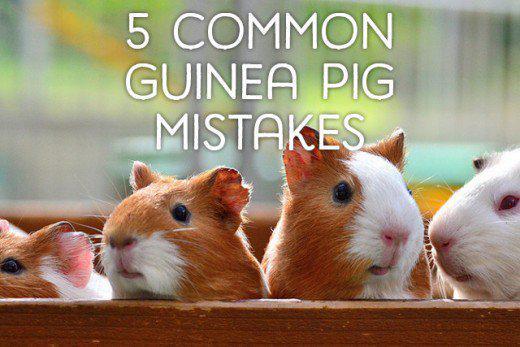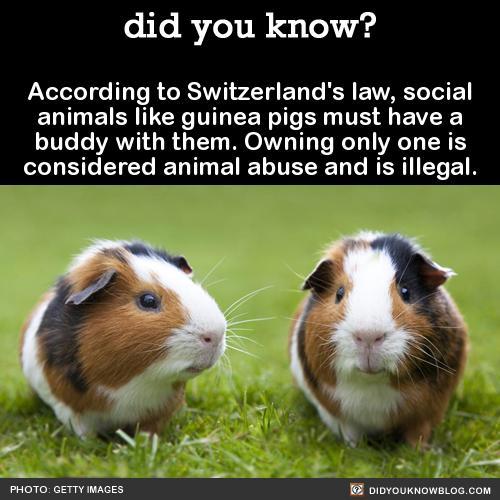The first image is the image on the left, the second image is the image on the right. For the images displayed, is the sentence "There is at least one guinea pig with food in its mouth" factually correct? Answer yes or no. No. The first image is the image on the left, the second image is the image on the right. Analyze the images presented: Is the assertion "guinea pigs have food in their mouths" valid? Answer yes or no. No. 